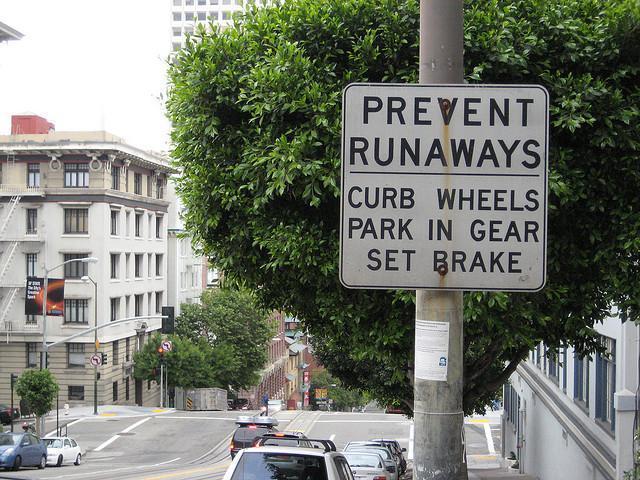What type vehicle does this sign refer to?
Select the accurate response from the four choices given to answer the question.
Options: Large truck, bike, roller blade, mini bike. Large truck. 